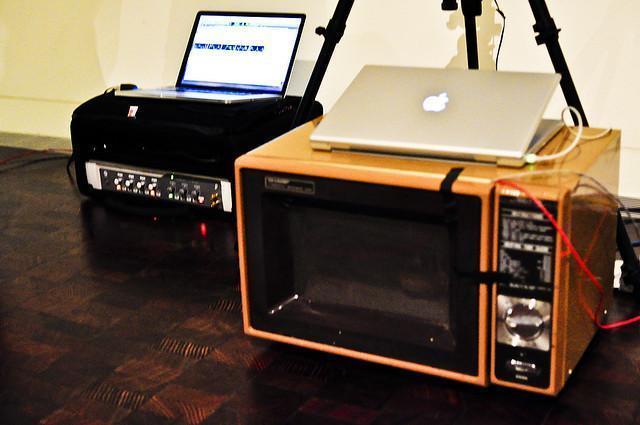How many laptops are in the photo?
Give a very brief answer. 2. 